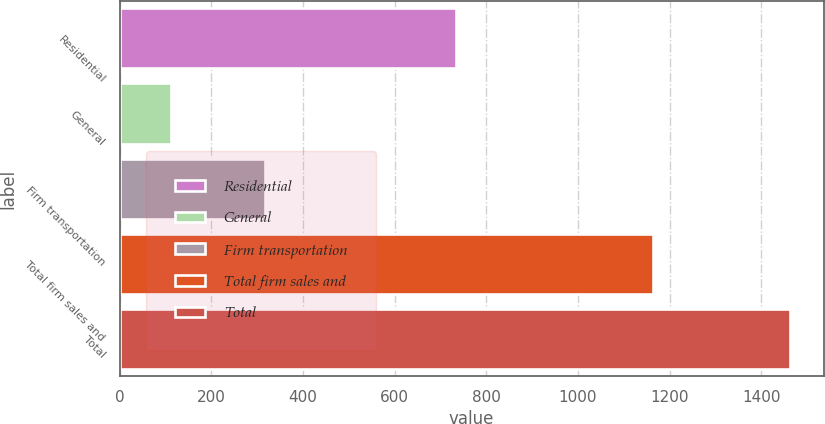Convert chart to OTSL. <chart><loc_0><loc_0><loc_500><loc_500><bar_chart><fcel>Residential<fcel>General<fcel>Firm transportation<fcel>Total firm sales and<fcel>Total<nl><fcel>733<fcel>112<fcel>318<fcel>1163<fcel>1463<nl></chart> 